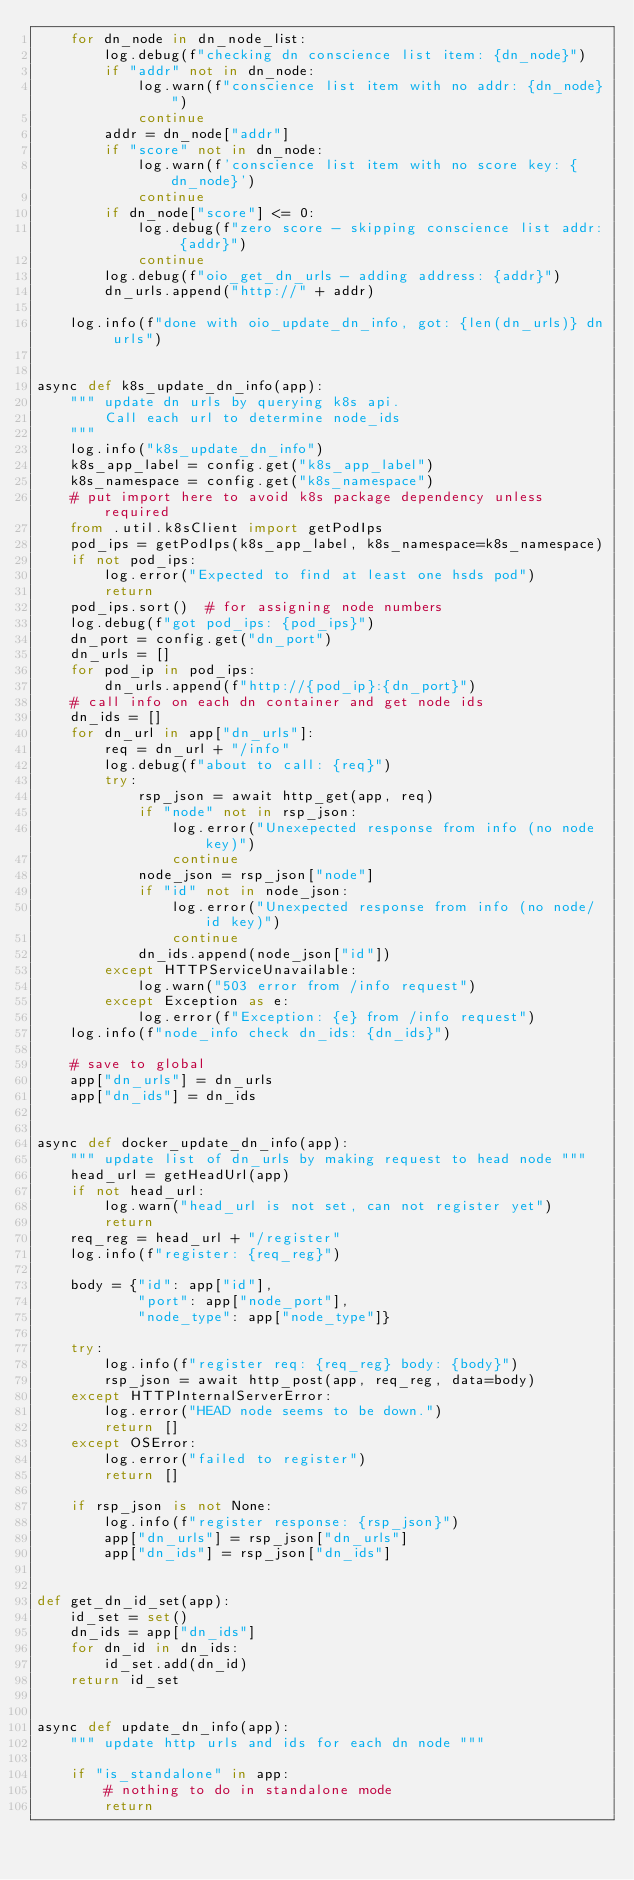<code> <loc_0><loc_0><loc_500><loc_500><_Python_>    for dn_node in dn_node_list:
        log.debug(f"checking dn conscience list item: {dn_node}")
        if "addr" not in dn_node:
            log.warn(f"conscience list item with no addr: {dn_node}")
            continue
        addr = dn_node["addr"]
        if "score" not in dn_node:
            log.warn(f'conscience list item with no score key: {dn_node}')
            continue
        if dn_node["score"] <= 0:
            log.debug(f"zero score - skipping conscience list addr: {addr}")
            continue
        log.debug(f"oio_get_dn_urls - adding address: {addr}")
        dn_urls.append("http://" + addr)

    log.info(f"done with oio_update_dn_info, got: {len(dn_urls)} dn urls")


async def k8s_update_dn_info(app):
    """ update dn urls by querying k8s api.
        Call each url to determine node_ids
    """
    log.info("k8s_update_dn_info")
    k8s_app_label = config.get("k8s_app_label")
    k8s_namespace = config.get("k8s_namespace")
    # put import here to avoid k8s package dependency unless required
    from .util.k8sClient import getPodIps
    pod_ips = getPodIps(k8s_app_label, k8s_namespace=k8s_namespace)
    if not pod_ips:
        log.error("Expected to find at least one hsds pod")
        return
    pod_ips.sort()  # for assigning node numbers
    log.debug(f"got pod_ips: {pod_ips}")
    dn_port = config.get("dn_port")
    dn_urls = []
    for pod_ip in pod_ips:
        dn_urls.append(f"http://{pod_ip}:{dn_port}")
    # call info on each dn container and get node ids
    dn_ids = []
    for dn_url in app["dn_urls"]:
        req = dn_url + "/info"
        log.debug(f"about to call: {req}")
        try:
            rsp_json = await http_get(app, req)
            if "node" not in rsp_json:
                log.error("Unexepected response from info (no node key)")
                continue
            node_json = rsp_json["node"]
            if "id" not in node_json:
                log.error("Unexpected response from info (no node/id key)")
                continue
            dn_ids.append(node_json["id"])
        except HTTPServiceUnavailable:
            log.warn("503 error from /info request")
        except Exception as e:
            log.error(f"Exception: {e} from /info request")
    log.info(f"node_info check dn_ids: {dn_ids}")

    # save to global
    app["dn_urls"] = dn_urls
    app["dn_ids"] = dn_ids


async def docker_update_dn_info(app):
    """ update list of dn_urls by making request to head node """
    head_url = getHeadUrl(app)
    if not head_url:
        log.warn("head_url is not set, can not register yet")
        return
    req_reg = head_url + "/register"
    log.info(f"register: {req_reg}")

    body = {"id": app["id"],
            "port": app["node_port"],
            "node_type": app["node_type"]}

    try:
        log.info(f"register req: {req_reg} body: {body}")
        rsp_json = await http_post(app, req_reg, data=body)
    except HTTPInternalServerError:
        log.error("HEAD node seems to be down.")
        return []
    except OSError:
        log.error("failed to register")
        return []

    if rsp_json is not None:
        log.info(f"register response: {rsp_json}")
        app["dn_urls"] = rsp_json["dn_urls"]
        app["dn_ids"] = rsp_json["dn_ids"]


def get_dn_id_set(app):
    id_set = set()
    dn_ids = app["dn_ids"]
    for dn_id in dn_ids:
        id_set.add(dn_id)
    return id_set


async def update_dn_info(app):
    """ update http urls and ids for each dn node """

    if "is_standalone" in app:
        # nothing to do in standalone mode
        return
</code> 